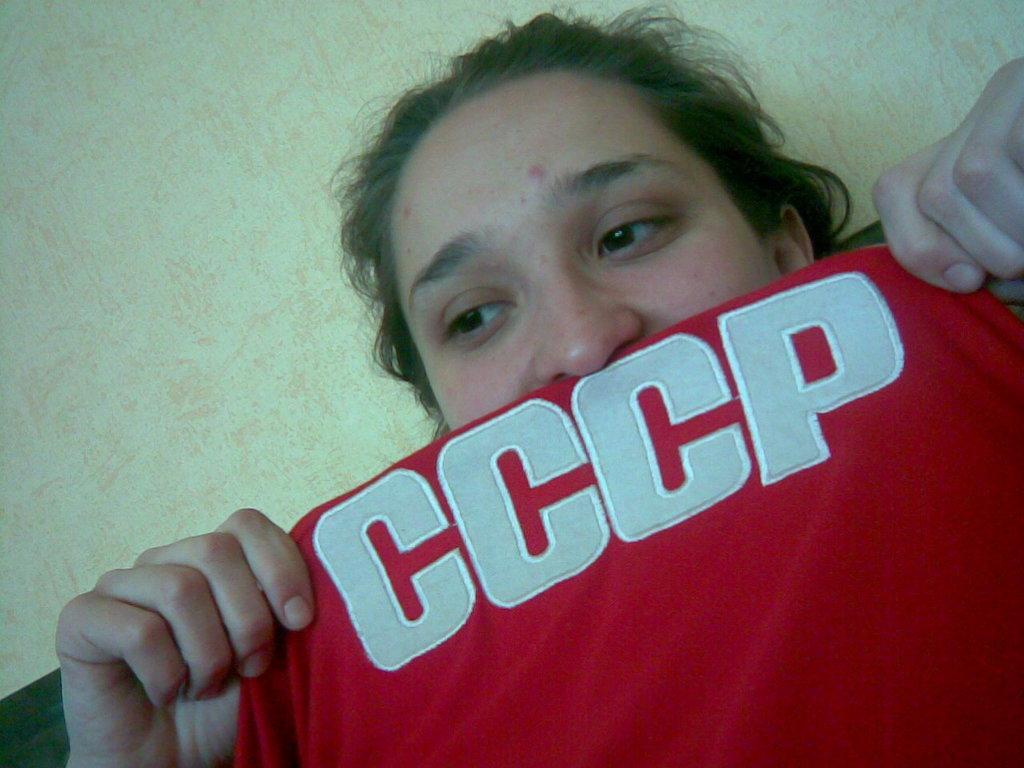Please provide a concise description of this image. In this image there is a woman holding red T-shirt in her hand, on that there is some text. 